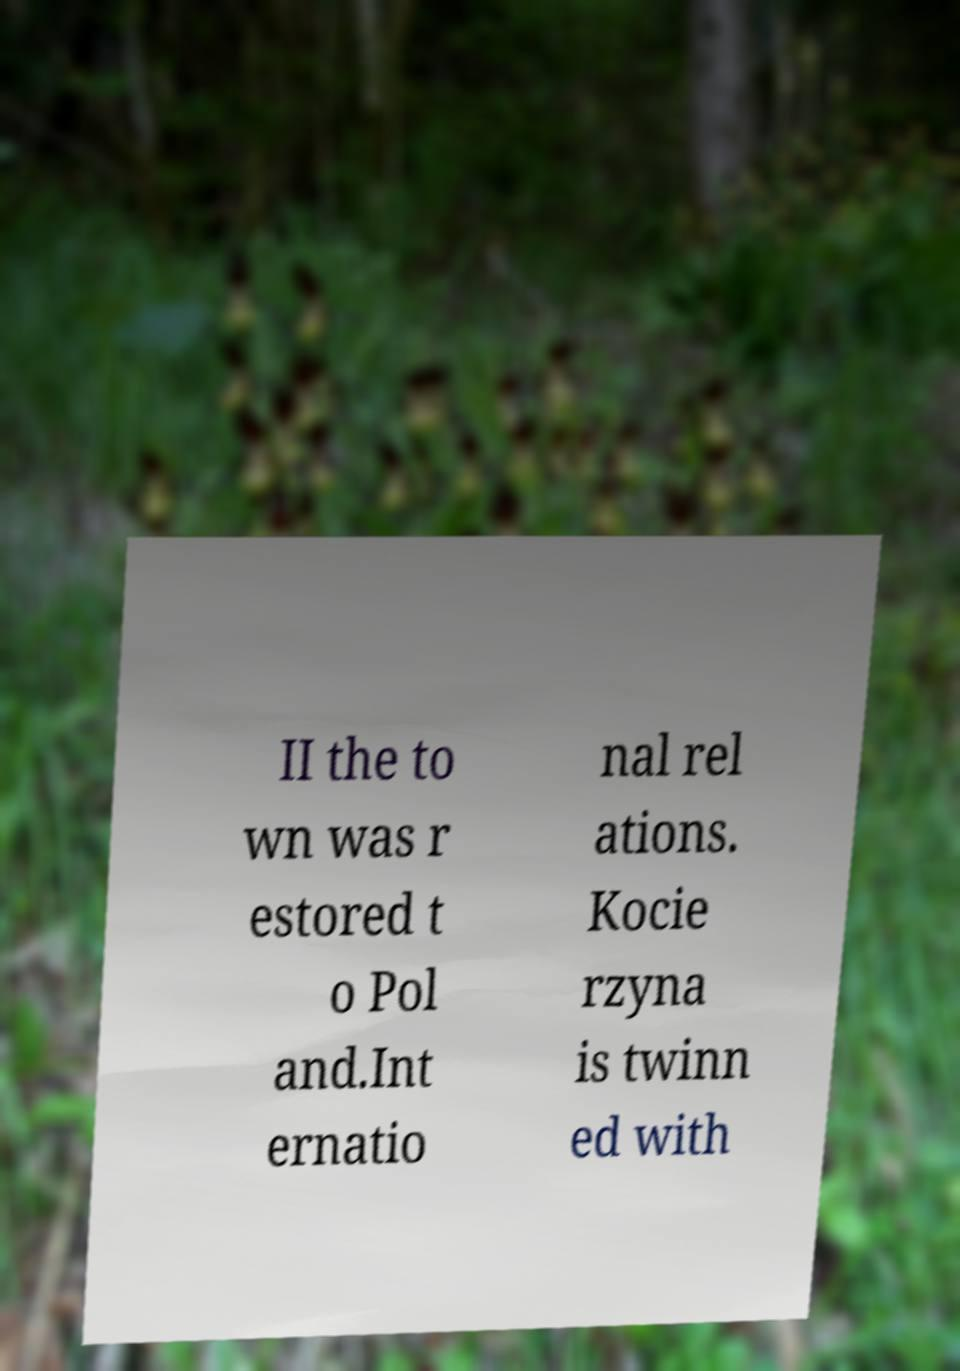For documentation purposes, I need the text within this image transcribed. Could you provide that? II the to wn was r estored t o Pol and.Int ernatio nal rel ations. Kocie rzyna is twinn ed with 